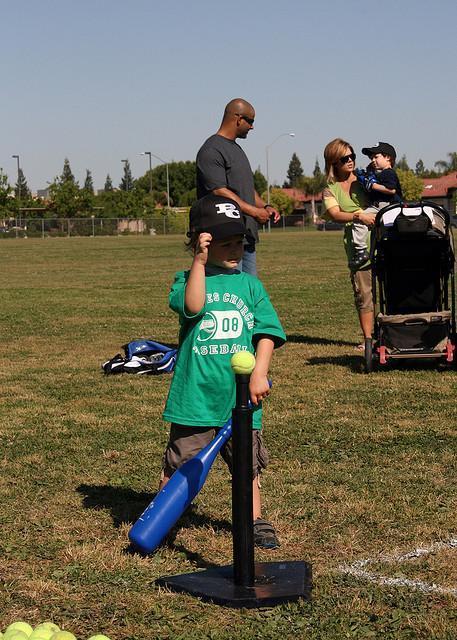How many people can you see?
Give a very brief answer. 4. How many umbrellas are there?
Give a very brief answer. 0. 